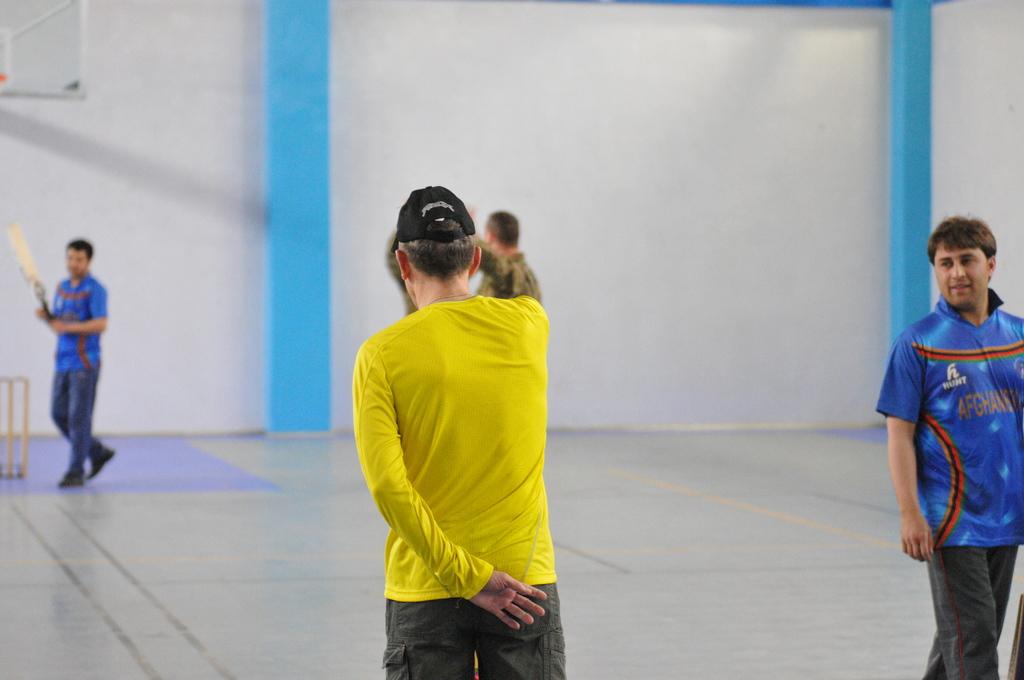What does the logo say on his shirt?
Offer a very short reply. Hunt. 